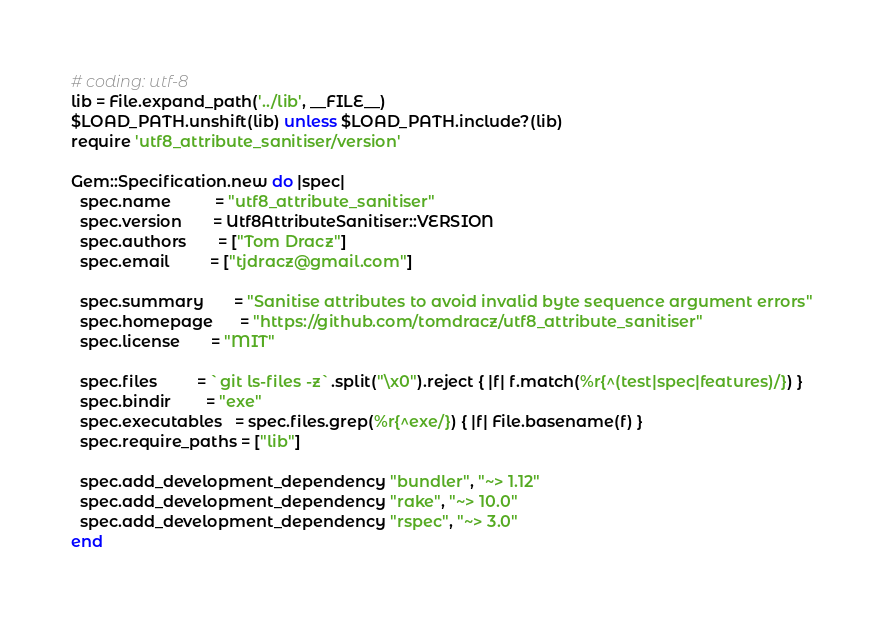Convert code to text. <code><loc_0><loc_0><loc_500><loc_500><_Ruby_># coding: utf-8
lib = File.expand_path('../lib', __FILE__)
$LOAD_PATH.unshift(lib) unless $LOAD_PATH.include?(lib)
require 'utf8_attribute_sanitiser/version'

Gem::Specification.new do |spec|
  spec.name          = "utf8_attribute_sanitiser"
  spec.version       = Utf8AttributeSanitiser::VERSION
  spec.authors       = ["Tom Dracz"]
  spec.email         = ["tjdracz@gmail.com"]

  spec.summary       = "Sanitise attributes to avoid invalid byte sequence argument errors"
  spec.homepage      = "https://github.com/tomdracz/utf8_attribute_sanitiser"
  spec.license       = "MIT"

  spec.files         = `git ls-files -z`.split("\x0").reject { |f| f.match(%r{^(test|spec|features)/}) }
  spec.bindir        = "exe"
  spec.executables   = spec.files.grep(%r{^exe/}) { |f| File.basename(f) }
  spec.require_paths = ["lib"]

  spec.add_development_dependency "bundler", "~> 1.12"
  spec.add_development_dependency "rake", "~> 10.0"
  spec.add_development_dependency "rspec", "~> 3.0"
end
</code> 